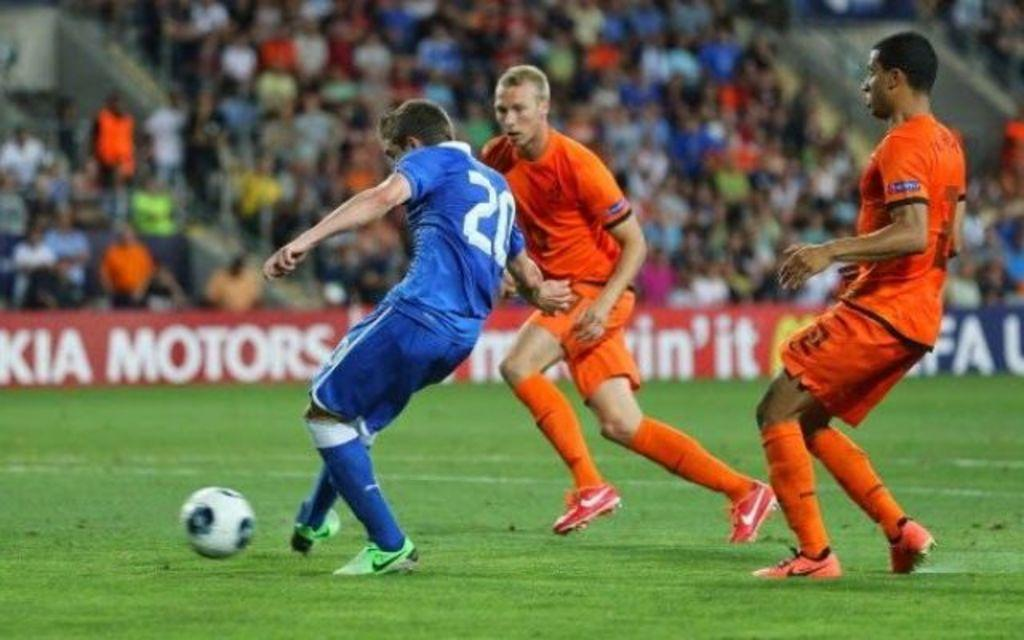How many people are in the image? There are three persons in the image. What are the persons doing in the image? The persons are playing a game with a ball. Where is the game being played? The game is being played on the grass. Can you describe the background of the image? The background of the image is blurred. What else can be seen in the image besides the persons playing the game? Banners are present in the image, and there are also people visible. What type of actor can be seen performing in the bedroom in the image? There is no actor or bedroom present in the image; it features three persons playing a game with a ball on the grass. What type of apparatus is being used by the persons in the image? The persons are using a ball to play their game, but there is no other apparatus visible in the image. 